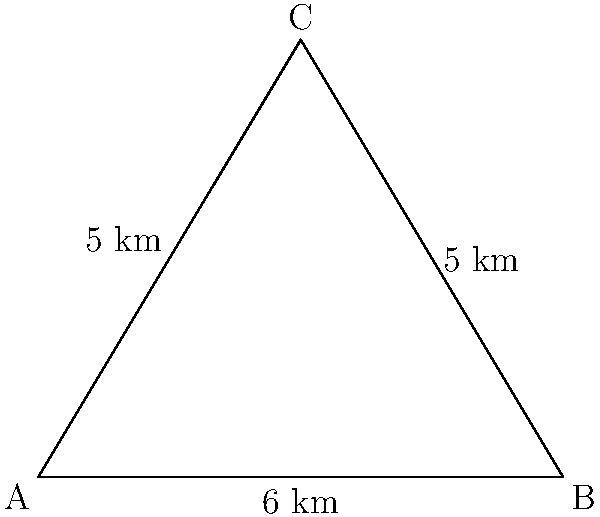In a captivating novel set on a remote tropical island, the author describes a triangular-shaped bay. The bay's shoreline forms an isosceles triangle with two sides measuring 5 km each and a base of 6 km. As a literary critic analyzing the geographical aspects of the story, calculate the area of this triangular bay in square kilometers. To find the area of the triangular bay, we can use Heron's formula. Let's approach this step-by-step:

1) First, we need to identify the sides of the triangle:
   $a = 5$ km, $b = 5$ km, $c = 6$ km

2) Calculate the semi-perimeter $s$:
   $s = \frac{a + b + c}{2} = \frac{5 + 5 + 6}{2} = 8$ km

3) Now we can apply Heron's formula:
   $A = \sqrt{s(s-a)(s-b)(s-c)}$

4) Substituting the values:
   $A = \sqrt{8(8-5)(8-5)(8-6)}$
   $A = \sqrt{8 \cdot 3 \cdot 3 \cdot 2}$
   $A = \sqrt{144}$

5) Simplify:
   $A = 12$ sq km

Therefore, the area of the triangular bay is 12 square kilometers.
Answer: 12 sq km 